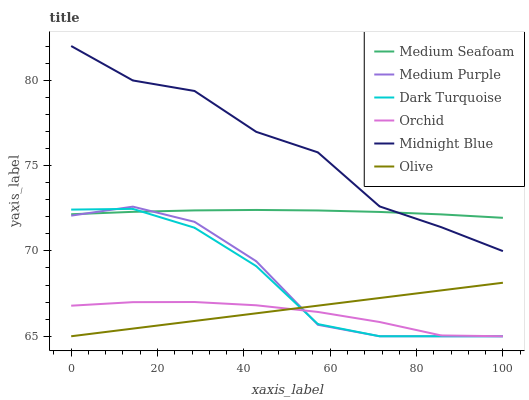Does Orchid have the minimum area under the curve?
Answer yes or no. Yes. Does Midnight Blue have the maximum area under the curve?
Answer yes or no. Yes. Does Dark Turquoise have the minimum area under the curve?
Answer yes or no. No. Does Dark Turquoise have the maximum area under the curve?
Answer yes or no. No. Is Olive the smoothest?
Answer yes or no. Yes. Is Midnight Blue the roughest?
Answer yes or no. Yes. Is Dark Turquoise the smoothest?
Answer yes or no. No. Is Dark Turquoise the roughest?
Answer yes or no. No. Does Medium Seafoam have the lowest value?
Answer yes or no. No. Does Midnight Blue have the highest value?
Answer yes or no. Yes. Does Dark Turquoise have the highest value?
Answer yes or no. No. Is Orchid less than Medium Seafoam?
Answer yes or no. Yes. Is Midnight Blue greater than Medium Purple?
Answer yes or no. Yes. Does Olive intersect Medium Purple?
Answer yes or no. Yes. Is Olive less than Medium Purple?
Answer yes or no. No. Is Olive greater than Medium Purple?
Answer yes or no. No. Does Orchid intersect Medium Seafoam?
Answer yes or no. No. 